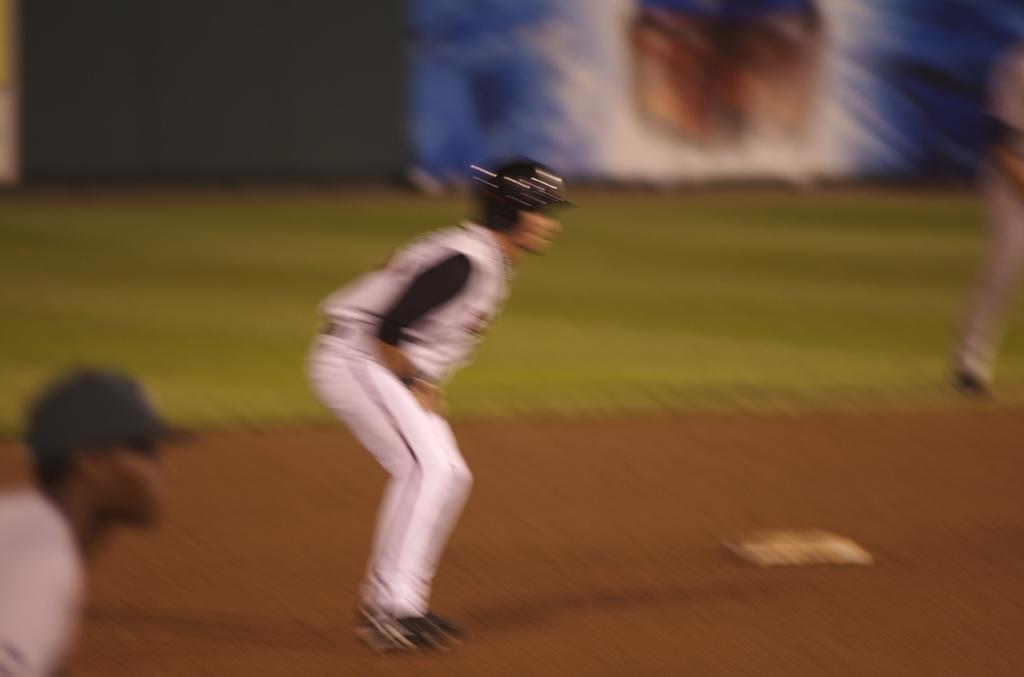Describe this image in one or two sentences. In this image there is a ground, in that ground there are three men standing and it is blurred. 